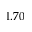<formula> <loc_0><loc_0><loc_500><loc_500>1 . 7 0</formula> 